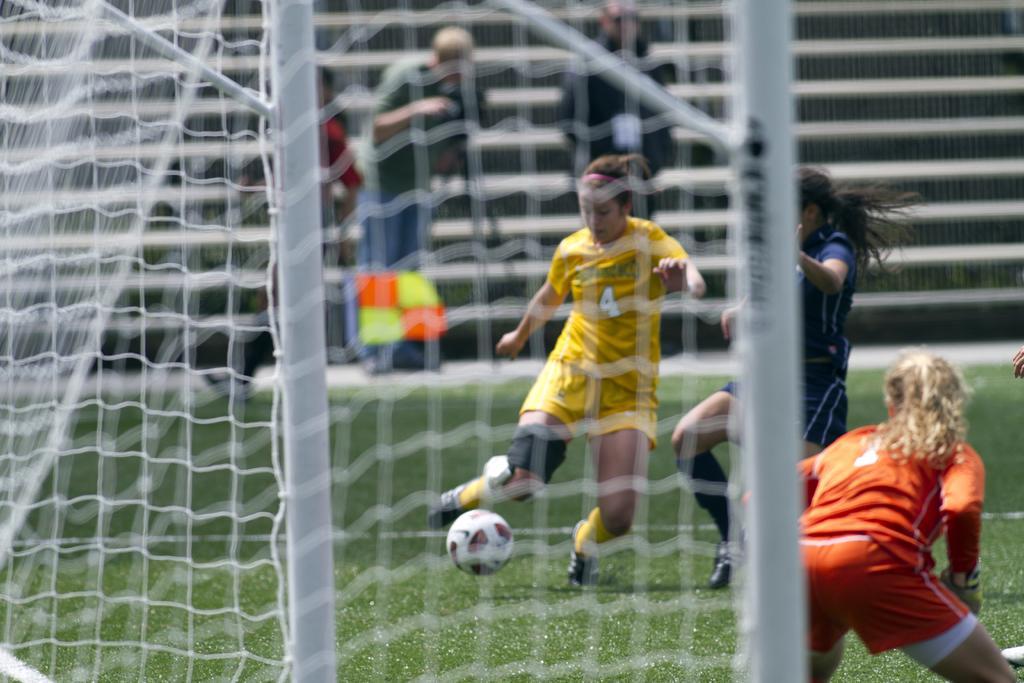How would you summarize this image in a sentence or two? In this picture we can see womans playing in a playground. This is a ball. On the stairs we can see persons standing and sitting. This is a net in white colour. 